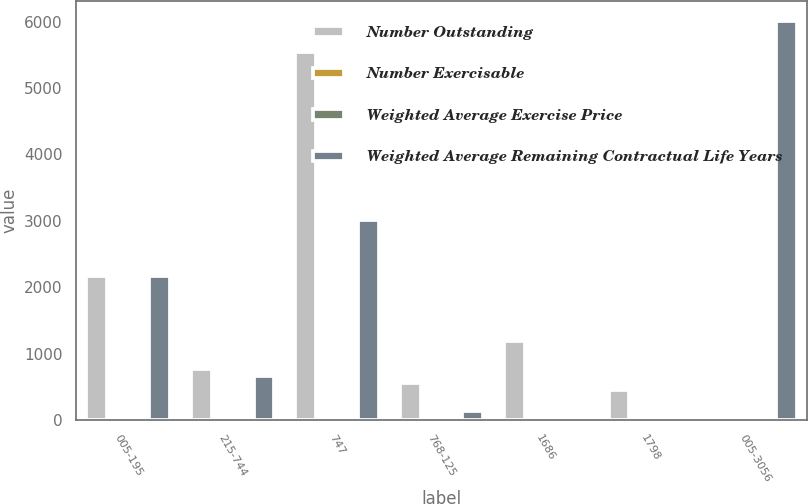Convert chart to OTSL. <chart><loc_0><loc_0><loc_500><loc_500><stacked_bar_chart><ecel><fcel>005-195<fcel>215-744<fcel>747<fcel>768-125<fcel>1686<fcel>1798<fcel>005-3056<nl><fcel>Number Outstanding<fcel>2175<fcel>775<fcel>5538<fcel>566<fcel>1193<fcel>452<fcel>16.86<nl><fcel>Number Exercisable<fcel>3.45<fcel>5.21<fcel>4.58<fcel>5.53<fcel>6.11<fcel>6.59<fcel>4.8<nl><fcel>Weighted Average Exercise Price<fcel>1.33<fcel>3.33<fcel>7.47<fcel>9.56<fcel>16.86<fcel>17.98<fcel>8.42<nl><fcel>Weighted Average Remaining Contractual Life Years<fcel>2175<fcel>662<fcel>3012<fcel>132<fcel>18<fcel>7<fcel>6006<nl></chart> 